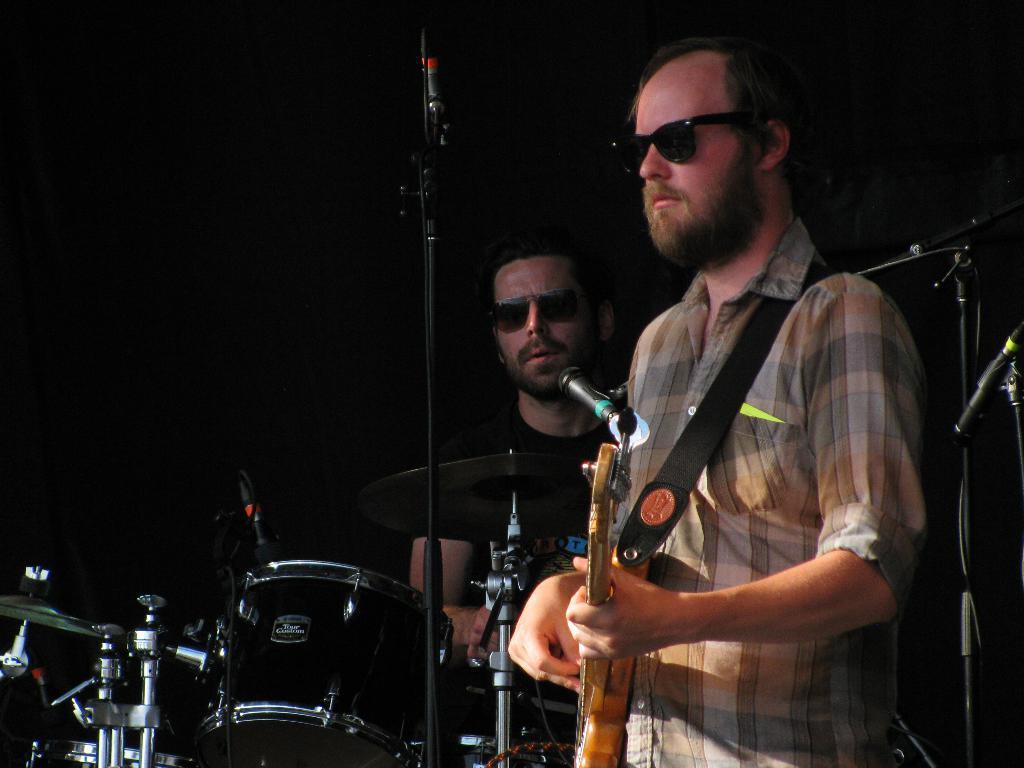Describe this image in one or two sentences. In this picture i could see a person holding a guitar in his hand and other person is beating the drums, there is mic in front of them and i could see a black back ground. 